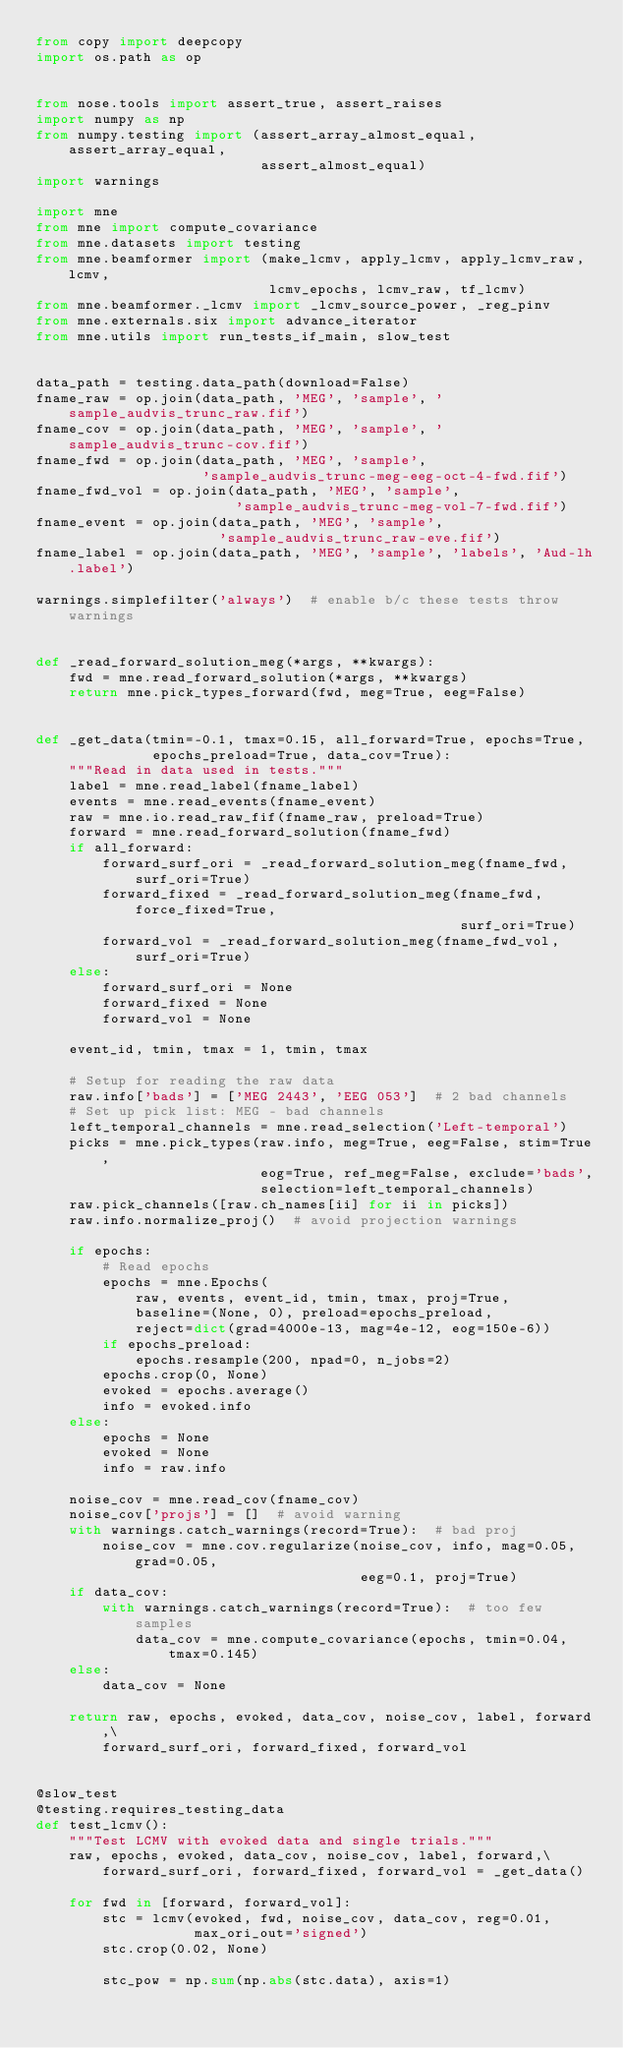Convert code to text. <code><loc_0><loc_0><loc_500><loc_500><_Python_>from copy import deepcopy
import os.path as op


from nose.tools import assert_true, assert_raises
import numpy as np
from numpy.testing import (assert_array_almost_equal, assert_array_equal,
                           assert_almost_equal)
import warnings

import mne
from mne import compute_covariance
from mne.datasets import testing
from mne.beamformer import (make_lcmv, apply_lcmv, apply_lcmv_raw, lcmv,
                            lcmv_epochs, lcmv_raw, tf_lcmv)
from mne.beamformer._lcmv import _lcmv_source_power, _reg_pinv
from mne.externals.six import advance_iterator
from mne.utils import run_tests_if_main, slow_test


data_path = testing.data_path(download=False)
fname_raw = op.join(data_path, 'MEG', 'sample', 'sample_audvis_trunc_raw.fif')
fname_cov = op.join(data_path, 'MEG', 'sample', 'sample_audvis_trunc-cov.fif')
fname_fwd = op.join(data_path, 'MEG', 'sample',
                    'sample_audvis_trunc-meg-eeg-oct-4-fwd.fif')
fname_fwd_vol = op.join(data_path, 'MEG', 'sample',
                        'sample_audvis_trunc-meg-vol-7-fwd.fif')
fname_event = op.join(data_path, 'MEG', 'sample',
                      'sample_audvis_trunc_raw-eve.fif')
fname_label = op.join(data_path, 'MEG', 'sample', 'labels', 'Aud-lh.label')

warnings.simplefilter('always')  # enable b/c these tests throw warnings


def _read_forward_solution_meg(*args, **kwargs):
    fwd = mne.read_forward_solution(*args, **kwargs)
    return mne.pick_types_forward(fwd, meg=True, eeg=False)


def _get_data(tmin=-0.1, tmax=0.15, all_forward=True, epochs=True,
              epochs_preload=True, data_cov=True):
    """Read in data used in tests."""
    label = mne.read_label(fname_label)
    events = mne.read_events(fname_event)
    raw = mne.io.read_raw_fif(fname_raw, preload=True)
    forward = mne.read_forward_solution(fname_fwd)
    if all_forward:
        forward_surf_ori = _read_forward_solution_meg(fname_fwd, surf_ori=True)
        forward_fixed = _read_forward_solution_meg(fname_fwd, force_fixed=True,
                                                   surf_ori=True)
        forward_vol = _read_forward_solution_meg(fname_fwd_vol, surf_ori=True)
    else:
        forward_surf_ori = None
        forward_fixed = None
        forward_vol = None

    event_id, tmin, tmax = 1, tmin, tmax

    # Setup for reading the raw data
    raw.info['bads'] = ['MEG 2443', 'EEG 053']  # 2 bad channels
    # Set up pick list: MEG - bad channels
    left_temporal_channels = mne.read_selection('Left-temporal')
    picks = mne.pick_types(raw.info, meg=True, eeg=False, stim=True,
                           eog=True, ref_meg=False, exclude='bads',
                           selection=left_temporal_channels)
    raw.pick_channels([raw.ch_names[ii] for ii in picks])
    raw.info.normalize_proj()  # avoid projection warnings

    if epochs:
        # Read epochs
        epochs = mne.Epochs(
            raw, events, event_id, tmin, tmax, proj=True,
            baseline=(None, 0), preload=epochs_preload,
            reject=dict(grad=4000e-13, mag=4e-12, eog=150e-6))
        if epochs_preload:
            epochs.resample(200, npad=0, n_jobs=2)
        epochs.crop(0, None)
        evoked = epochs.average()
        info = evoked.info
    else:
        epochs = None
        evoked = None
        info = raw.info

    noise_cov = mne.read_cov(fname_cov)
    noise_cov['projs'] = []  # avoid warning
    with warnings.catch_warnings(record=True):  # bad proj
        noise_cov = mne.cov.regularize(noise_cov, info, mag=0.05, grad=0.05,
                                       eeg=0.1, proj=True)
    if data_cov:
        with warnings.catch_warnings(record=True):  # too few samples
            data_cov = mne.compute_covariance(epochs, tmin=0.04, tmax=0.145)
    else:
        data_cov = None

    return raw, epochs, evoked, data_cov, noise_cov, label, forward,\
        forward_surf_ori, forward_fixed, forward_vol


@slow_test
@testing.requires_testing_data
def test_lcmv():
    """Test LCMV with evoked data and single trials."""
    raw, epochs, evoked, data_cov, noise_cov, label, forward,\
        forward_surf_ori, forward_fixed, forward_vol = _get_data()

    for fwd in [forward, forward_vol]:
        stc = lcmv(evoked, fwd, noise_cov, data_cov, reg=0.01,
                   max_ori_out='signed')
        stc.crop(0.02, None)

        stc_pow = np.sum(np.abs(stc.data), axis=1)</code> 